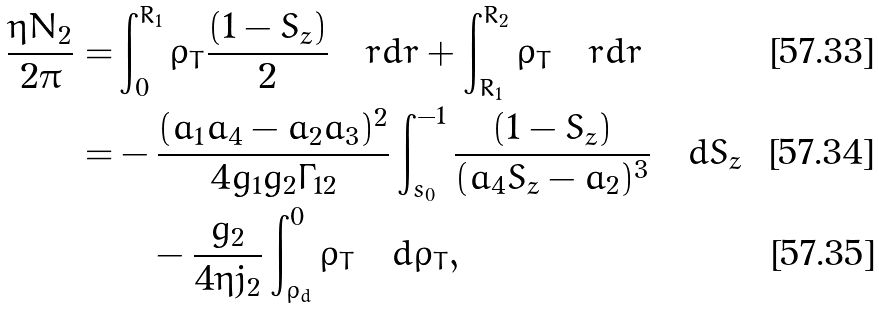<formula> <loc_0><loc_0><loc_500><loc_500>\frac { \eta { N } _ { 2 } } { 2 \pi } = & \int _ { 0 } ^ { R _ { 1 } } \rho _ { T } \frac { ( 1 - S _ { z } ) } { 2 } \quad r d r + \int _ { R _ { 1 } } ^ { R _ { 2 } } \rho _ { T } \quad r d r \\ = & - \frac { ( a _ { 1 } a _ { 4 } - a _ { 2 } a _ { 3 } ) ^ { 2 } } { 4 g _ { 1 } g _ { 2 } \Gamma _ { 1 2 } } \int _ { s _ { 0 } } ^ { - 1 } \frac { ( 1 - S _ { z } ) } { ( a _ { 4 } S _ { z } - a _ { 2 } ) ^ { 3 } } \quad d S _ { z } \\ & \quad - \frac { g _ { 2 } } { 4 \eta j _ { 2 } } \int _ { \rho _ { d } } ^ { 0 } \rho _ { T } \quad d \rho _ { T } ,</formula> 